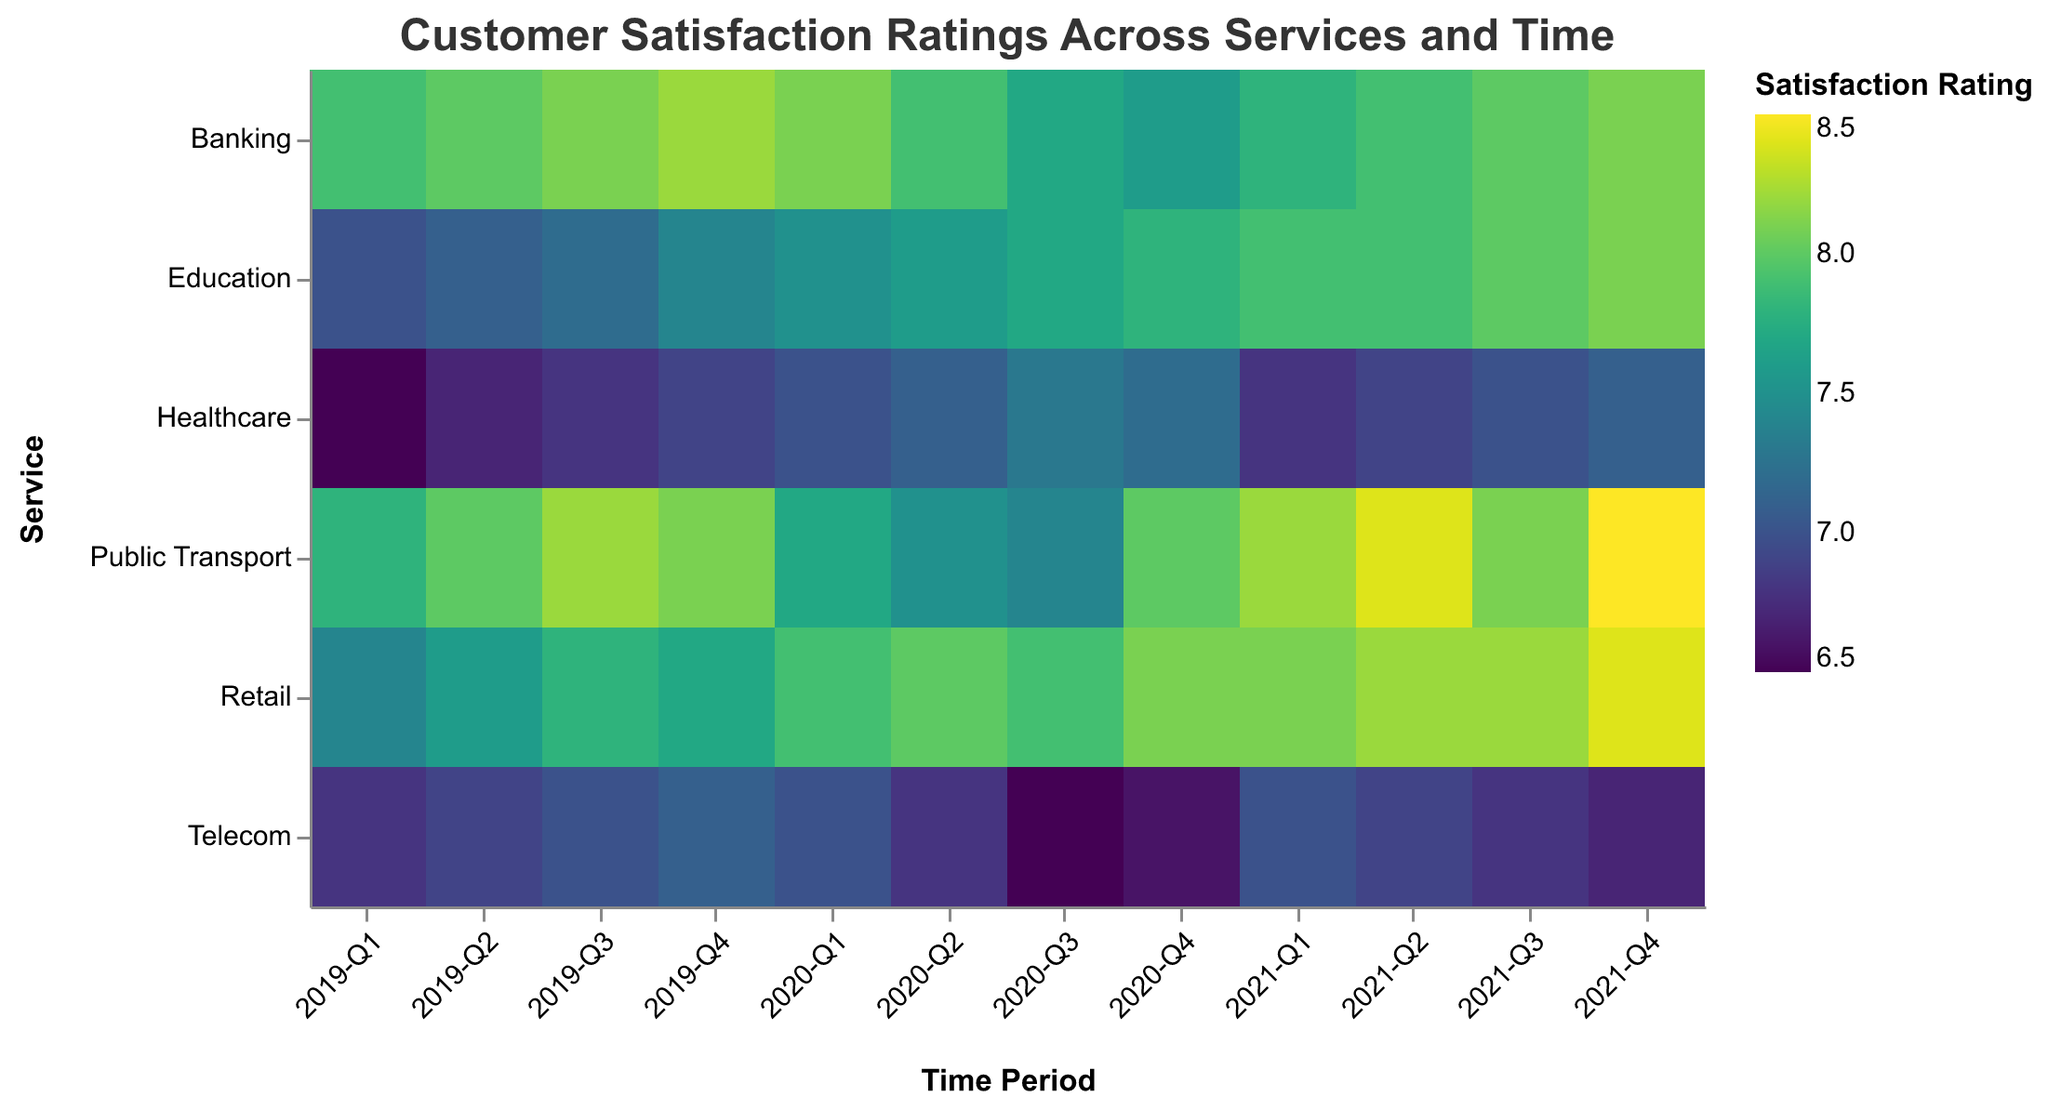What is the title of the heatmap? The title of the heatmap is displayed at the top and reads: "Customer Satisfaction Ratings Across Services and Time".
Answer: Customer Satisfaction Ratings Across Services and Time Which time period shows the highest satisfaction rating for Public Transport? Looking at the row for Public Transport across different time periods, the highest satisfaction rating is at "2021-Q4" with a value of 8.5.
Answer: 2021-Q4 How did the satisfaction ratings for Healthcare change from 2019-Q1 to 2021-Q4? For Healthcare, follow the cells from "2019-Q1" to "2021-Q4": starting at 6.5, increasing to 6.7, 6.8, 6.9, 7.0, 7.1, 7.3, 7.2, down to 6.8, and ending at 7.1.
Answer: Increased from 6.5 to 7.1 Which service had the highest average satisfaction rating in 2020? To calculate the average satisfaction rating for each service in 2020, sum the ratings for each quarter and divide by 4. Public Transport: (7.7 + 7.5 + 7.4 + 8.0)/4 = 7.65. Healthcare: (7.0 + 7.1 + 7.3 + 7.2)/4 = 7.15. Education: (7.5 + 7.6 + 7.7 + 7.8)/4 = 7.65. Telecom: (7.0 + 6.8 + 6.5 + 6.6)/4 = 6.725. Retail: (7.9 + 8.0 + 7.9 + 8.1)/4 = 7.975. Banking: (8.1 + 7.9 + 7.7 + 7.6)/4 = 7.825. Retail has the highest average rating of 7.975.
Answer: Retail Which service saw the largest single-quarter drop in satisfaction ratings, and in which quarter did it occur? Examine each cell to find the largest drop between any two quarters. Telecom from "2020-Q1" to "2020-Q2" dropped from 7.0 to 6.8 (a drop of 0.2), and "2020-Q2" to "2020-Q3" dropped from 6.8 to 6.5 (a drop of 0.3) which is the largest drop observed. Therefore, the largest drop was in Telecom between "2020-Q2" and "2020-Q3".
Answer: Telecom, 2020-Q2 to 2020-Q3 Comparing Education and Telecom, which service had the most consistent satisfaction ratings over the three-year period? Consistency can be defined by smaller fluctuations in ratings. Education ranges from 7.0 to 8.1 (total range: 1.1). Telecom ranges from 6.5 to 7.1 (total range: 0.6). Although Telecom has a smaller range, it has more frequent drops, notably a significant drop from 7.0 to 6.5. Education has a steady increase overall. Thus, Education is more consistent overall.
Answer: Education Which quarter in 2020 had the lowest overall satisfaction rating across all services? Sum the satisfaction ratings for each quarter in 2020: 2020-Q1 = (7.7 + 7.0 + 7.5 + 7.0 + 7.9 + 8.1) = 45.2, 2020-Q2 = (7.5 + 7.1 + 7.6 + 6.8 + 8.0 + 7.9) = 44.9, 2020-Q3 = (7.4 + 7.3 + 7.7 + 6.5 + 7.9 + 7.7) = 44.5, 2020-Q4 = (8.0 + 7.2 + 7.8 + 6.6 + 8.1 + 7.6) = 45.3. 2020-Q3 has the lowest sum.
Answer: 2020-Q3 What trend do you observe for the Retail satisfaction rating over the three years? Follow the Retail row: starting at 7.4 in "2019-Q1" and generally increasing, except for a small dip in "2020-Q3" from 8.0 to 7.9, before rising to 8.4 in "2021-Q4". The overall trend is an increase in satisfaction rating.
Answer: Generally increasing Which services had a satisfaction rating of 8.0 or higher in 2021-Q2? Look at the "2021-Q2" column and identify ratings 8.0 or above. Public Transport (8.4), Retail (8.2), and Banking (7.9 < 8.0, so not included).
Answer: Public Transport, Retail Which service had the most variability in satisfaction ratings across all periods? Calculate the range for each service: Public Transport (7.4 - 8.5 = 1.1), Healthcare (6.5 - 7.3 = 0.8), Education (7.0 - 8.1 = 1.1), Telecom (6.5 - 7.1 = 0.6), Retail (7.4 - 8.4 = 1.0), Banking (7.6 - 8.2 = 0.6). Both Public Transport and Education have the highest range of 1.1, indicating they have the most variability.
Answer: Public Transport, Education 